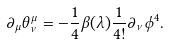Convert formula to latex. <formula><loc_0><loc_0><loc_500><loc_500>\partial _ { \mu } \theta ^ { \mu } _ { \nu } = - \frac { 1 } { 4 } \beta ( \lambda ) \frac { 1 } { 4 ! } \partial _ { \nu } \phi ^ { 4 } .</formula> 